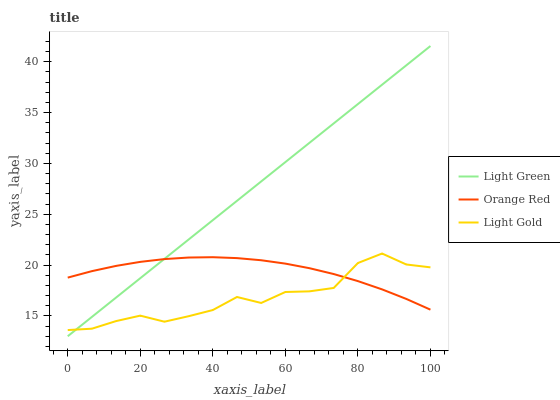Does Light Gold have the minimum area under the curve?
Answer yes or no. Yes. Does Light Green have the maximum area under the curve?
Answer yes or no. Yes. Does Orange Red have the minimum area under the curve?
Answer yes or no. No. Does Orange Red have the maximum area under the curve?
Answer yes or no. No. Is Light Green the smoothest?
Answer yes or no. Yes. Is Light Gold the roughest?
Answer yes or no. Yes. Is Orange Red the smoothest?
Answer yes or no. No. Is Orange Red the roughest?
Answer yes or no. No. Does Light Green have the lowest value?
Answer yes or no. Yes. Does Orange Red have the lowest value?
Answer yes or no. No. Does Light Green have the highest value?
Answer yes or no. Yes. Does Orange Red have the highest value?
Answer yes or no. No. Does Light Green intersect Light Gold?
Answer yes or no. Yes. Is Light Green less than Light Gold?
Answer yes or no. No. Is Light Green greater than Light Gold?
Answer yes or no. No. 